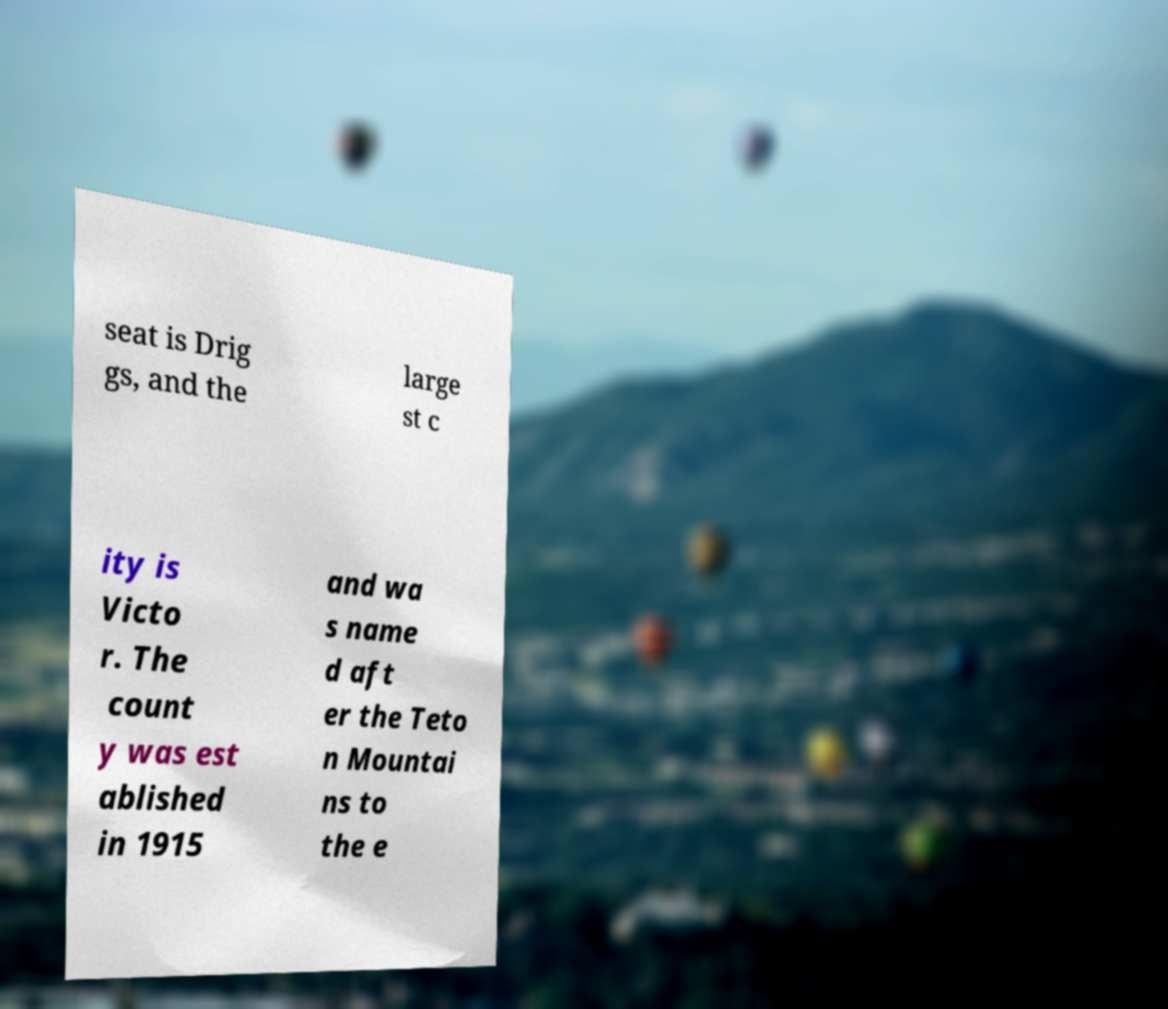Can you accurately transcribe the text from the provided image for me? seat is Drig gs, and the large st c ity is Victo r. The count y was est ablished in 1915 and wa s name d aft er the Teto n Mountai ns to the e 